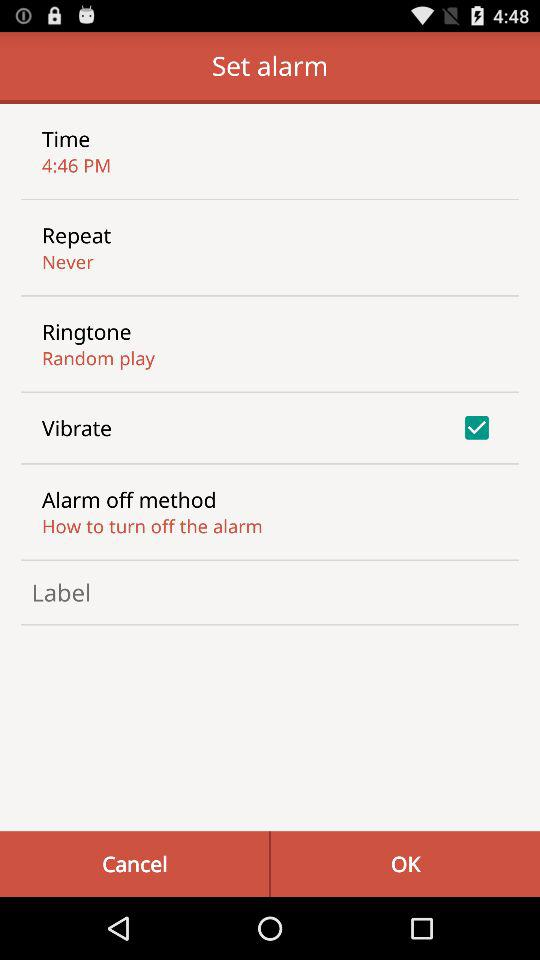Which time is selected? The selected time is 4:46 PM. 